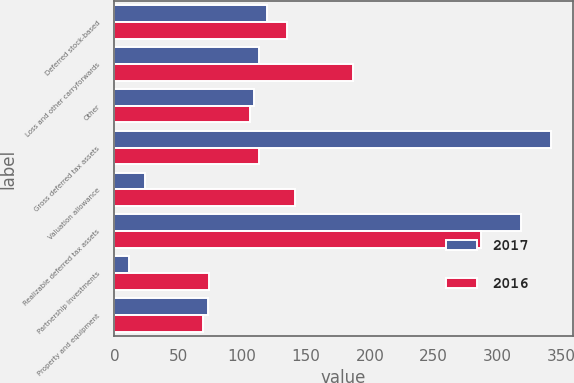Convert chart. <chart><loc_0><loc_0><loc_500><loc_500><stacked_bar_chart><ecel><fcel>Deferred stock-based<fcel>Loss and other carryforwards<fcel>Other<fcel>Gross deferred tax assets<fcel>Valuation allowance<fcel>Realizable deferred tax assets<fcel>Partnership investments<fcel>Property and equipment<nl><fcel>2017<fcel>119.6<fcel>113<fcel>109.2<fcel>341.8<fcel>23.6<fcel>318.2<fcel>11.5<fcel>72.9<nl><fcel>2016<fcel>135<fcel>187.2<fcel>106.1<fcel>113<fcel>141.6<fcel>286.7<fcel>74.2<fcel>69.4<nl></chart> 